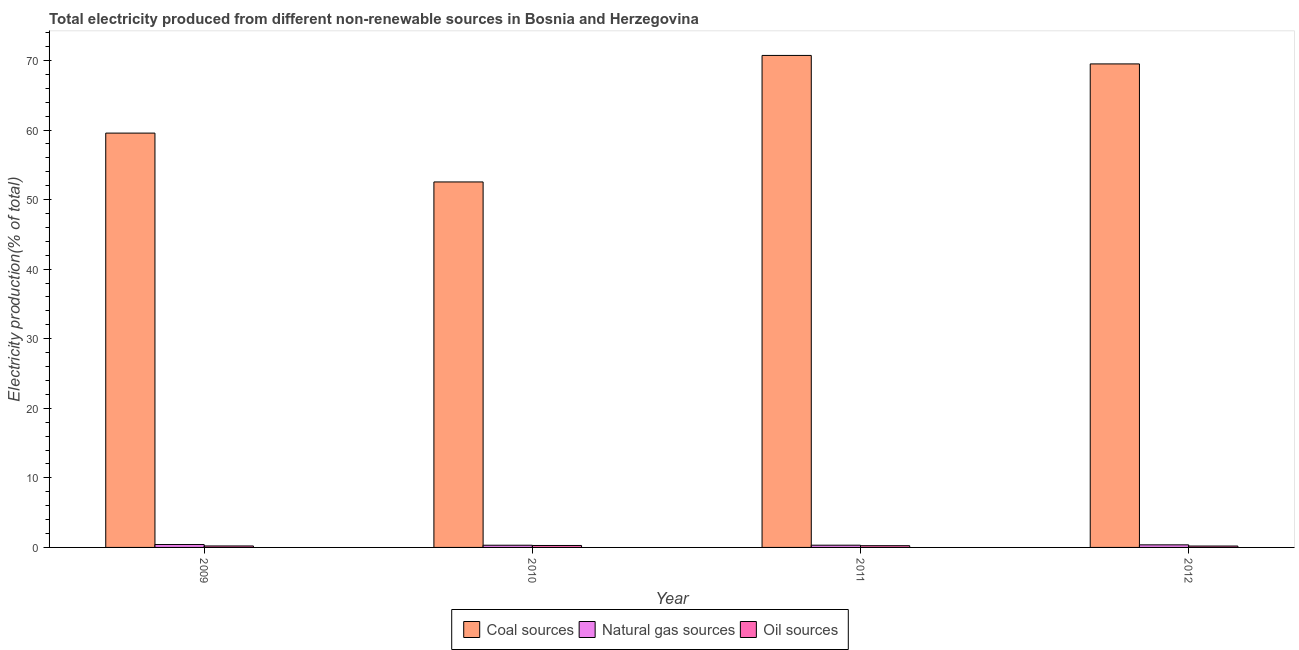How many different coloured bars are there?
Ensure brevity in your answer.  3. How many groups of bars are there?
Keep it short and to the point. 4. What is the label of the 1st group of bars from the left?
Give a very brief answer. 2009. In how many cases, is the number of bars for a given year not equal to the number of legend labels?
Make the answer very short. 0. What is the percentage of electricity produced by coal in 2012?
Offer a terse response. 69.5. Across all years, what is the maximum percentage of electricity produced by natural gas?
Provide a succinct answer. 0.41. Across all years, what is the minimum percentage of electricity produced by coal?
Give a very brief answer. 52.53. In which year was the percentage of electricity produced by coal maximum?
Give a very brief answer. 2011. What is the total percentage of electricity produced by coal in the graph?
Ensure brevity in your answer.  252.31. What is the difference between the percentage of electricity produced by coal in 2009 and that in 2011?
Give a very brief answer. -11.17. What is the difference between the percentage of electricity produced by coal in 2010 and the percentage of electricity produced by natural gas in 2009?
Provide a short and direct response. -7.02. What is the average percentage of electricity produced by oil sources per year?
Ensure brevity in your answer.  0.23. In the year 2010, what is the difference between the percentage of electricity produced by oil sources and percentage of electricity produced by natural gas?
Your response must be concise. 0. In how many years, is the percentage of electricity produced by coal greater than 40 %?
Your answer should be very brief. 4. What is the ratio of the percentage of electricity produced by oil sources in 2010 to that in 2012?
Provide a succinct answer. 1.41. Is the percentage of electricity produced by coal in 2009 less than that in 2011?
Ensure brevity in your answer.  Yes. What is the difference between the highest and the second highest percentage of electricity produced by coal?
Make the answer very short. 1.22. What is the difference between the highest and the lowest percentage of electricity produced by coal?
Your response must be concise. 18.19. What does the 3rd bar from the left in 2010 represents?
Your response must be concise. Oil sources. What does the 1st bar from the right in 2010 represents?
Your answer should be very brief. Oil sources. Is it the case that in every year, the sum of the percentage of electricity produced by coal and percentage of electricity produced by natural gas is greater than the percentage of electricity produced by oil sources?
Provide a succinct answer. Yes. How many bars are there?
Provide a short and direct response. 12. Are all the bars in the graph horizontal?
Your answer should be compact. No. How many years are there in the graph?
Your answer should be compact. 4. Are the values on the major ticks of Y-axis written in scientific E-notation?
Keep it short and to the point. No. Does the graph contain any zero values?
Your answer should be very brief. No. How are the legend labels stacked?
Your answer should be very brief. Horizontal. What is the title of the graph?
Make the answer very short. Total electricity produced from different non-renewable sources in Bosnia and Herzegovina. Does "Domestic economy" appear as one of the legend labels in the graph?
Make the answer very short. No. What is the label or title of the Y-axis?
Make the answer very short. Electricity production(% of total). What is the Electricity production(% of total) in Coal sources in 2009?
Offer a very short reply. 59.55. What is the Electricity production(% of total) in Natural gas sources in 2009?
Give a very brief answer. 0.41. What is the Electricity production(% of total) in Oil sources in 2009?
Offer a very short reply. 0.21. What is the Electricity production(% of total) in Coal sources in 2010?
Provide a short and direct response. 52.53. What is the Electricity production(% of total) of Natural gas sources in 2010?
Keep it short and to the point. 0.32. What is the Electricity production(% of total) of Oil sources in 2010?
Offer a very short reply. 0.28. What is the Electricity production(% of total) in Coal sources in 2011?
Make the answer very short. 70.72. What is the Electricity production(% of total) in Natural gas sources in 2011?
Make the answer very short. 0.32. What is the Electricity production(% of total) of Oil sources in 2011?
Keep it short and to the point. 0.25. What is the Electricity production(% of total) in Coal sources in 2012?
Make the answer very short. 69.5. What is the Electricity production(% of total) in Natural gas sources in 2012?
Provide a succinct answer. 0.37. What is the Electricity production(% of total) in Oil sources in 2012?
Give a very brief answer. 0.2. Across all years, what is the maximum Electricity production(% of total) in Coal sources?
Make the answer very short. 70.72. Across all years, what is the maximum Electricity production(% of total) in Natural gas sources?
Provide a short and direct response. 0.41. Across all years, what is the maximum Electricity production(% of total) in Oil sources?
Your response must be concise. 0.28. Across all years, what is the minimum Electricity production(% of total) of Coal sources?
Your answer should be very brief. 52.53. Across all years, what is the minimum Electricity production(% of total) of Natural gas sources?
Provide a short and direct response. 0.32. Across all years, what is the minimum Electricity production(% of total) of Oil sources?
Your response must be concise. 0.2. What is the total Electricity production(% of total) in Coal sources in the graph?
Your response must be concise. 252.31. What is the total Electricity production(% of total) of Natural gas sources in the graph?
Your answer should be compact. 1.42. What is the total Electricity production(% of total) in Oil sources in the graph?
Keep it short and to the point. 0.94. What is the difference between the Electricity production(% of total) of Coal sources in 2009 and that in 2010?
Offer a very short reply. 7.02. What is the difference between the Electricity production(% of total) in Natural gas sources in 2009 and that in 2010?
Offer a terse response. 0.1. What is the difference between the Electricity production(% of total) in Oil sources in 2009 and that in 2010?
Give a very brief answer. -0.07. What is the difference between the Electricity production(% of total) of Coal sources in 2009 and that in 2011?
Offer a very short reply. -11.17. What is the difference between the Electricity production(% of total) in Natural gas sources in 2009 and that in 2011?
Make the answer very short. 0.09. What is the difference between the Electricity production(% of total) in Oil sources in 2009 and that in 2011?
Provide a succinct answer. -0.04. What is the difference between the Electricity production(% of total) of Coal sources in 2009 and that in 2012?
Offer a terse response. -9.95. What is the difference between the Electricity production(% of total) in Natural gas sources in 2009 and that in 2012?
Keep it short and to the point. 0.05. What is the difference between the Electricity production(% of total) of Oil sources in 2009 and that in 2012?
Give a very brief answer. 0.01. What is the difference between the Electricity production(% of total) of Coal sources in 2010 and that in 2011?
Your response must be concise. -18.19. What is the difference between the Electricity production(% of total) of Natural gas sources in 2010 and that in 2011?
Offer a very short reply. -0.01. What is the difference between the Electricity production(% of total) of Oil sources in 2010 and that in 2011?
Provide a short and direct response. 0.03. What is the difference between the Electricity production(% of total) in Coal sources in 2010 and that in 2012?
Make the answer very short. -16.97. What is the difference between the Electricity production(% of total) of Natural gas sources in 2010 and that in 2012?
Make the answer very short. -0.05. What is the difference between the Electricity production(% of total) of Oil sources in 2010 and that in 2012?
Make the answer very short. 0.08. What is the difference between the Electricity production(% of total) in Coal sources in 2011 and that in 2012?
Ensure brevity in your answer.  1.22. What is the difference between the Electricity production(% of total) in Natural gas sources in 2011 and that in 2012?
Provide a succinct answer. -0.05. What is the difference between the Electricity production(% of total) in Oil sources in 2011 and that in 2012?
Make the answer very short. 0.05. What is the difference between the Electricity production(% of total) of Coal sources in 2009 and the Electricity production(% of total) of Natural gas sources in 2010?
Your answer should be compact. 59.24. What is the difference between the Electricity production(% of total) in Coal sources in 2009 and the Electricity production(% of total) in Oil sources in 2010?
Ensure brevity in your answer.  59.27. What is the difference between the Electricity production(% of total) of Natural gas sources in 2009 and the Electricity production(% of total) of Oil sources in 2010?
Your response must be concise. 0.13. What is the difference between the Electricity production(% of total) of Coal sources in 2009 and the Electricity production(% of total) of Natural gas sources in 2011?
Keep it short and to the point. 59.23. What is the difference between the Electricity production(% of total) in Coal sources in 2009 and the Electricity production(% of total) in Oil sources in 2011?
Your response must be concise. 59.31. What is the difference between the Electricity production(% of total) in Natural gas sources in 2009 and the Electricity production(% of total) in Oil sources in 2011?
Ensure brevity in your answer.  0.17. What is the difference between the Electricity production(% of total) in Coal sources in 2009 and the Electricity production(% of total) in Natural gas sources in 2012?
Give a very brief answer. 59.19. What is the difference between the Electricity production(% of total) of Coal sources in 2009 and the Electricity production(% of total) of Oil sources in 2012?
Keep it short and to the point. 59.36. What is the difference between the Electricity production(% of total) in Natural gas sources in 2009 and the Electricity production(% of total) in Oil sources in 2012?
Offer a terse response. 0.22. What is the difference between the Electricity production(% of total) of Coal sources in 2010 and the Electricity production(% of total) of Natural gas sources in 2011?
Provide a succinct answer. 52.21. What is the difference between the Electricity production(% of total) of Coal sources in 2010 and the Electricity production(% of total) of Oil sources in 2011?
Give a very brief answer. 52.29. What is the difference between the Electricity production(% of total) of Natural gas sources in 2010 and the Electricity production(% of total) of Oil sources in 2011?
Offer a very short reply. 0.07. What is the difference between the Electricity production(% of total) in Coal sources in 2010 and the Electricity production(% of total) in Natural gas sources in 2012?
Ensure brevity in your answer.  52.17. What is the difference between the Electricity production(% of total) in Coal sources in 2010 and the Electricity production(% of total) in Oil sources in 2012?
Ensure brevity in your answer.  52.34. What is the difference between the Electricity production(% of total) in Natural gas sources in 2010 and the Electricity production(% of total) in Oil sources in 2012?
Make the answer very short. 0.12. What is the difference between the Electricity production(% of total) of Coal sources in 2011 and the Electricity production(% of total) of Natural gas sources in 2012?
Offer a very short reply. 70.35. What is the difference between the Electricity production(% of total) of Coal sources in 2011 and the Electricity production(% of total) of Oil sources in 2012?
Your response must be concise. 70.52. What is the difference between the Electricity production(% of total) in Natural gas sources in 2011 and the Electricity production(% of total) in Oil sources in 2012?
Your answer should be very brief. 0.12. What is the average Electricity production(% of total) in Coal sources per year?
Provide a short and direct response. 63.08. What is the average Electricity production(% of total) in Natural gas sources per year?
Make the answer very short. 0.35. What is the average Electricity production(% of total) of Oil sources per year?
Offer a very short reply. 0.23. In the year 2009, what is the difference between the Electricity production(% of total) in Coal sources and Electricity production(% of total) in Natural gas sources?
Your answer should be compact. 59.14. In the year 2009, what is the difference between the Electricity production(% of total) of Coal sources and Electricity production(% of total) of Oil sources?
Offer a very short reply. 59.34. In the year 2009, what is the difference between the Electricity production(% of total) of Natural gas sources and Electricity production(% of total) of Oil sources?
Your response must be concise. 0.2. In the year 2010, what is the difference between the Electricity production(% of total) in Coal sources and Electricity production(% of total) in Natural gas sources?
Provide a succinct answer. 52.22. In the year 2010, what is the difference between the Electricity production(% of total) of Coal sources and Electricity production(% of total) of Oil sources?
Your answer should be very brief. 52.25. In the year 2010, what is the difference between the Electricity production(% of total) of Natural gas sources and Electricity production(% of total) of Oil sources?
Provide a succinct answer. 0.04. In the year 2011, what is the difference between the Electricity production(% of total) in Coal sources and Electricity production(% of total) in Natural gas sources?
Provide a short and direct response. 70.4. In the year 2011, what is the difference between the Electricity production(% of total) of Coal sources and Electricity production(% of total) of Oil sources?
Provide a short and direct response. 70.47. In the year 2011, what is the difference between the Electricity production(% of total) in Natural gas sources and Electricity production(% of total) in Oil sources?
Ensure brevity in your answer.  0.07. In the year 2012, what is the difference between the Electricity production(% of total) in Coal sources and Electricity production(% of total) in Natural gas sources?
Provide a succinct answer. 69.13. In the year 2012, what is the difference between the Electricity production(% of total) in Coal sources and Electricity production(% of total) in Oil sources?
Your response must be concise. 69.3. In the year 2012, what is the difference between the Electricity production(% of total) in Natural gas sources and Electricity production(% of total) in Oil sources?
Provide a succinct answer. 0.17. What is the ratio of the Electricity production(% of total) of Coal sources in 2009 to that in 2010?
Your answer should be very brief. 1.13. What is the ratio of the Electricity production(% of total) in Natural gas sources in 2009 to that in 2010?
Ensure brevity in your answer.  1.32. What is the ratio of the Electricity production(% of total) in Oil sources in 2009 to that in 2010?
Provide a short and direct response. 0.75. What is the ratio of the Electricity production(% of total) in Coal sources in 2009 to that in 2011?
Provide a short and direct response. 0.84. What is the ratio of the Electricity production(% of total) in Natural gas sources in 2009 to that in 2011?
Ensure brevity in your answer.  1.29. What is the ratio of the Electricity production(% of total) in Oil sources in 2009 to that in 2011?
Keep it short and to the point. 0.85. What is the ratio of the Electricity production(% of total) in Coal sources in 2009 to that in 2012?
Offer a very short reply. 0.86. What is the ratio of the Electricity production(% of total) of Natural gas sources in 2009 to that in 2012?
Offer a terse response. 1.12. What is the ratio of the Electricity production(% of total) of Oil sources in 2009 to that in 2012?
Keep it short and to the point. 1.06. What is the ratio of the Electricity production(% of total) of Coal sources in 2010 to that in 2011?
Provide a succinct answer. 0.74. What is the ratio of the Electricity production(% of total) in Natural gas sources in 2010 to that in 2011?
Provide a succinct answer. 0.98. What is the ratio of the Electricity production(% of total) of Oil sources in 2010 to that in 2011?
Ensure brevity in your answer.  1.13. What is the ratio of the Electricity production(% of total) in Coal sources in 2010 to that in 2012?
Make the answer very short. 0.76. What is the ratio of the Electricity production(% of total) in Natural gas sources in 2010 to that in 2012?
Provide a short and direct response. 0.85. What is the ratio of the Electricity production(% of total) in Oil sources in 2010 to that in 2012?
Your answer should be very brief. 1.41. What is the ratio of the Electricity production(% of total) in Coal sources in 2011 to that in 2012?
Provide a succinct answer. 1.02. What is the ratio of the Electricity production(% of total) of Natural gas sources in 2011 to that in 2012?
Your answer should be very brief. 0.87. What is the ratio of the Electricity production(% of total) of Oil sources in 2011 to that in 2012?
Your answer should be very brief. 1.25. What is the difference between the highest and the second highest Electricity production(% of total) in Coal sources?
Your response must be concise. 1.22. What is the difference between the highest and the second highest Electricity production(% of total) in Natural gas sources?
Keep it short and to the point. 0.05. What is the difference between the highest and the second highest Electricity production(% of total) in Oil sources?
Ensure brevity in your answer.  0.03. What is the difference between the highest and the lowest Electricity production(% of total) in Coal sources?
Your response must be concise. 18.19. What is the difference between the highest and the lowest Electricity production(% of total) of Natural gas sources?
Your answer should be compact. 0.1. What is the difference between the highest and the lowest Electricity production(% of total) in Oil sources?
Offer a very short reply. 0.08. 